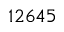<formula> <loc_0><loc_0><loc_500><loc_500>1 2 6 4 5</formula> 